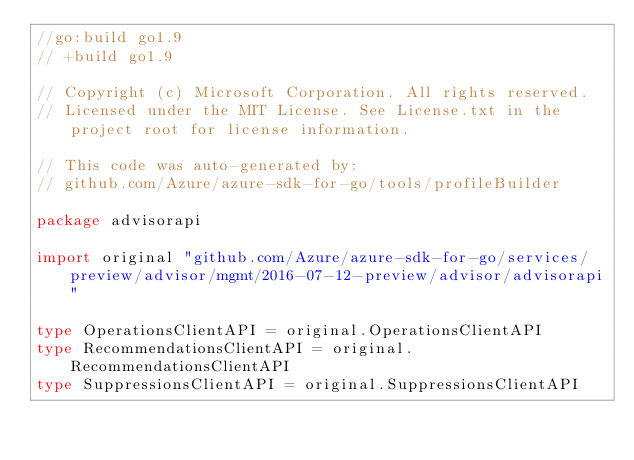<code> <loc_0><loc_0><loc_500><loc_500><_Go_>//go:build go1.9
// +build go1.9

// Copyright (c) Microsoft Corporation. All rights reserved.
// Licensed under the MIT License. See License.txt in the project root for license information.

// This code was auto-generated by:
// github.com/Azure/azure-sdk-for-go/tools/profileBuilder

package advisorapi

import original "github.com/Azure/azure-sdk-for-go/services/preview/advisor/mgmt/2016-07-12-preview/advisor/advisorapi"

type OperationsClientAPI = original.OperationsClientAPI
type RecommendationsClientAPI = original.RecommendationsClientAPI
type SuppressionsClientAPI = original.SuppressionsClientAPI
</code> 